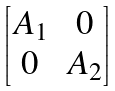Convert formula to latex. <formula><loc_0><loc_0><loc_500><loc_500>\begin{bmatrix} A _ { 1 } & 0 \\ 0 & A _ { 2 } \end{bmatrix}</formula> 